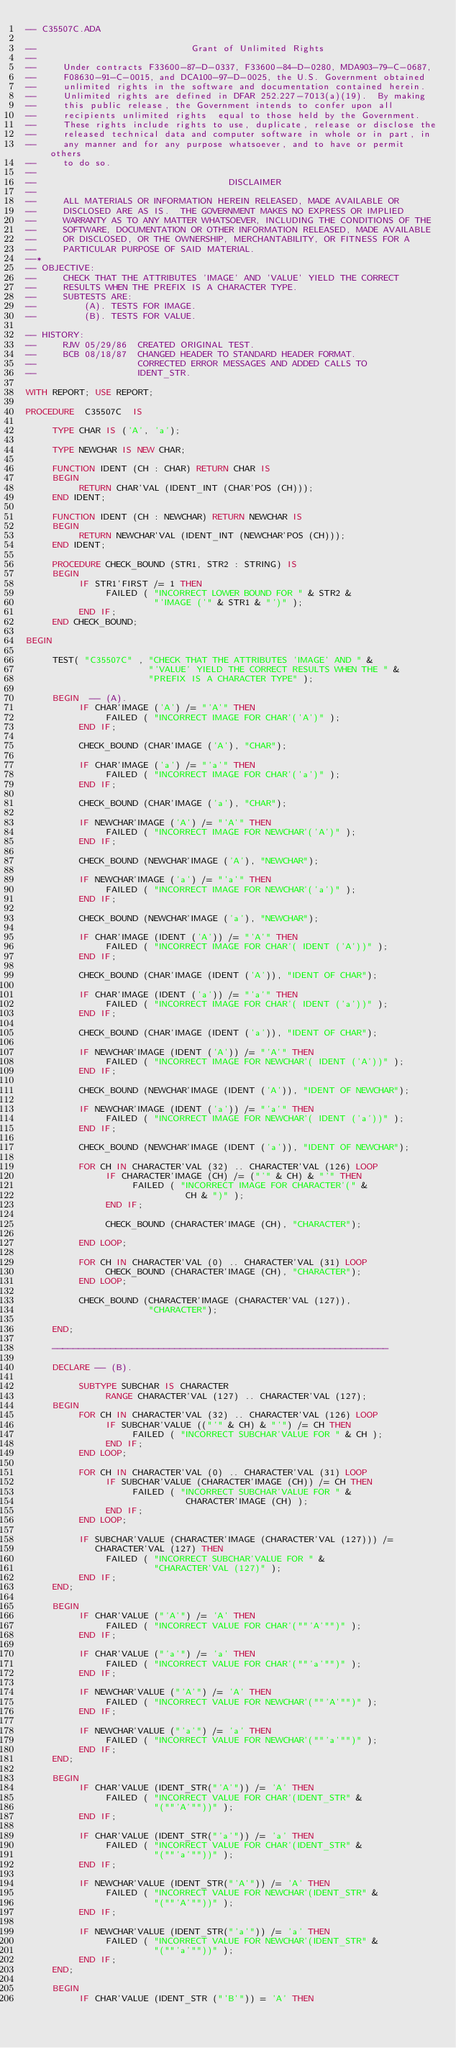Convert code to text. <code><loc_0><loc_0><loc_500><loc_500><_Ada_>-- C35507C.ADA

--                             Grant of Unlimited Rights
--
--     Under contracts F33600-87-D-0337, F33600-84-D-0280, MDA903-79-C-0687,
--     F08630-91-C-0015, and DCA100-97-D-0025, the U.S. Government obtained 
--     unlimited rights in the software and documentation contained herein.
--     Unlimited rights are defined in DFAR 252.227-7013(a)(19).  By making 
--     this public release, the Government intends to confer upon all 
--     recipients unlimited rights  equal to those held by the Government.  
--     These rights include rights to use, duplicate, release or disclose the 
--     released technical data and computer software in whole or in part, in 
--     any manner and for any purpose whatsoever, and to have or permit others 
--     to do so.
--
--                                    DISCLAIMER
--
--     ALL MATERIALS OR INFORMATION HEREIN RELEASED, MADE AVAILABLE OR
--     DISCLOSED ARE AS IS.  THE GOVERNMENT MAKES NO EXPRESS OR IMPLIED 
--     WARRANTY AS TO ANY MATTER WHATSOEVER, INCLUDING THE CONDITIONS OF THE
--     SOFTWARE, DOCUMENTATION OR OTHER INFORMATION RELEASED, MADE AVAILABLE 
--     OR DISCLOSED, OR THE OWNERSHIP, MERCHANTABILITY, OR FITNESS FOR A
--     PARTICULAR PURPOSE OF SAID MATERIAL.
--*
-- OBJECTIVE:
--     CHECK THAT THE ATTRIBUTES 'IMAGE' AND 'VALUE' YIELD THE CORRECT
--     RESULTS WHEN THE PREFIX IS A CHARACTER TYPE.
--     SUBTESTS ARE:
--         (A). TESTS FOR IMAGE.
--         (B). TESTS FOR VALUE.

-- HISTORY:
--     RJW 05/29/86  CREATED ORIGINAL TEST.
--     BCB 08/18/87  CHANGED HEADER TO STANDARD HEADER FORMAT.
--                   CORRECTED ERROR MESSAGES AND ADDED CALLS TO
--                   IDENT_STR.

WITH REPORT; USE REPORT;

PROCEDURE  C35507C  IS

     TYPE CHAR IS ('A', 'a');

     TYPE NEWCHAR IS NEW CHAR;

     FUNCTION IDENT (CH : CHAR) RETURN CHAR IS
     BEGIN
          RETURN CHAR'VAL (IDENT_INT (CHAR'POS (CH)));
     END IDENT;

     FUNCTION IDENT (CH : NEWCHAR) RETURN NEWCHAR IS
     BEGIN
          RETURN NEWCHAR'VAL (IDENT_INT (NEWCHAR'POS (CH)));
     END IDENT;

     PROCEDURE CHECK_BOUND (STR1, STR2 : STRING) IS
     BEGIN
          IF STR1'FIRST /= 1 THEN
               FAILED ( "INCORRECT LOWER BOUND FOR " & STR2 &
                        "'IMAGE ('" & STR1 & "')" );
          END IF;
     END CHECK_BOUND;

BEGIN

     TEST( "C35507C" , "CHECK THAT THE ATTRIBUTES 'IMAGE' AND " &
                       "'VALUE' YIELD THE CORRECT RESULTS WHEN THE " &
                       "PREFIX IS A CHARACTER TYPE" );

     BEGIN  -- (A).
          IF CHAR'IMAGE ('A') /= "'A'" THEN
               FAILED ( "INCORRECT IMAGE FOR CHAR'('A')" );
          END IF;

          CHECK_BOUND (CHAR'IMAGE ('A'), "CHAR");

          IF CHAR'IMAGE ('a') /= "'a'" THEN
               FAILED ( "INCORRECT IMAGE FOR CHAR'('a')" );
          END IF;

          CHECK_BOUND (CHAR'IMAGE ('a'), "CHAR");

          IF NEWCHAR'IMAGE ('A') /= "'A'" THEN
               FAILED ( "INCORRECT IMAGE FOR NEWCHAR'('A')" );
          END IF;

          CHECK_BOUND (NEWCHAR'IMAGE ('A'), "NEWCHAR");

          IF NEWCHAR'IMAGE ('a') /= "'a'" THEN
               FAILED ( "INCORRECT IMAGE FOR NEWCHAR'('a')" );
          END IF;

          CHECK_BOUND (NEWCHAR'IMAGE ('a'), "NEWCHAR");

          IF CHAR'IMAGE (IDENT ('A')) /= "'A'" THEN
               FAILED ( "INCORRECT IMAGE FOR CHAR'( IDENT ('A'))" );
          END IF;

          CHECK_BOUND (CHAR'IMAGE (IDENT ('A')), "IDENT OF CHAR");

          IF CHAR'IMAGE (IDENT ('a')) /= "'a'" THEN
               FAILED ( "INCORRECT IMAGE FOR CHAR'( IDENT ('a'))" );
          END IF;

          CHECK_BOUND (CHAR'IMAGE (IDENT ('a')), "IDENT OF CHAR");

          IF NEWCHAR'IMAGE (IDENT ('A')) /= "'A'" THEN
               FAILED ( "INCORRECT IMAGE FOR NEWCHAR'( IDENT ('A'))" );
          END IF;

          CHECK_BOUND (NEWCHAR'IMAGE (IDENT ('A')), "IDENT OF NEWCHAR");

          IF NEWCHAR'IMAGE (IDENT ('a')) /= "'a'" THEN
               FAILED ( "INCORRECT IMAGE FOR NEWCHAR'( IDENT ('a'))" );
          END IF;

          CHECK_BOUND (NEWCHAR'IMAGE (IDENT ('a')), "IDENT OF NEWCHAR");

          FOR CH IN CHARACTER'VAL (32) .. CHARACTER'VAL (126) LOOP
               IF CHARACTER'IMAGE (CH) /= ("'" & CH) & "'" THEN
                    FAILED ( "INCORRECT IMAGE FOR CHARACTER'(" &
                              CH & ")" );
               END IF;

               CHECK_BOUND (CHARACTER'IMAGE (CH), "CHARACTER");

          END LOOP;

          FOR CH IN CHARACTER'VAL (0) .. CHARACTER'VAL (31) LOOP
               CHECK_BOUND (CHARACTER'IMAGE (CH), "CHARACTER");
          END LOOP;

          CHECK_BOUND (CHARACTER'IMAGE (CHARACTER'VAL (127)),
                       "CHARACTER");

     END;

     ---------------------------------------------------------------

     DECLARE -- (B).

          SUBTYPE SUBCHAR IS CHARACTER
               RANGE CHARACTER'VAL (127) .. CHARACTER'VAL (127);
     BEGIN
          FOR CH IN CHARACTER'VAL (32) .. CHARACTER'VAL (126) LOOP
               IF SUBCHAR'VALUE (("'" & CH) & "'") /= CH THEN
                    FAILED ( "INCORRECT SUBCHAR'VALUE FOR " & CH );
               END IF;
          END LOOP;

          FOR CH IN CHARACTER'VAL (0) .. CHARACTER'VAL (31) LOOP
               IF SUBCHAR'VALUE (CHARACTER'IMAGE (CH)) /= CH THEN
                    FAILED ( "INCORRECT SUBCHAR'VALUE FOR " &
                              CHARACTER'IMAGE (CH) );
               END IF;
          END LOOP;

          IF SUBCHAR'VALUE (CHARACTER'IMAGE (CHARACTER'VAL (127))) /=
             CHARACTER'VAL (127) THEN
               FAILED ( "INCORRECT SUBCHAR'VALUE FOR " &
                        "CHARACTER'VAL (127)" );
          END IF;
     END;

     BEGIN
          IF CHAR'VALUE ("'A'") /= 'A' THEN
               FAILED ( "INCORRECT VALUE FOR CHAR'(""'A'"")" );
          END IF;

          IF CHAR'VALUE ("'a'") /= 'a' THEN
               FAILED ( "INCORRECT VALUE FOR CHAR'(""'a'"")" );
          END IF;

          IF NEWCHAR'VALUE ("'A'") /= 'A' THEN
               FAILED ( "INCORRECT VALUE FOR NEWCHAR'(""'A'"")" );
          END IF;

          IF NEWCHAR'VALUE ("'a'") /= 'a' THEN
               FAILED ( "INCORRECT VALUE FOR NEWCHAR'(""'a'"")" );
          END IF;
     END;

     BEGIN
          IF CHAR'VALUE (IDENT_STR("'A'")) /= 'A' THEN
               FAILED ( "INCORRECT VALUE FOR CHAR'(IDENT_STR" &
                        "(""'A'""))" );
          END IF;

          IF CHAR'VALUE (IDENT_STR("'a'")) /= 'a' THEN
               FAILED ( "INCORRECT VALUE FOR CHAR'(IDENT_STR" &
                        "(""'a'""))" );
          END IF;

          IF NEWCHAR'VALUE (IDENT_STR("'A'")) /= 'A' THEN
               FAILED ( "INCORRECT VALUE FOR NEWCHAR'(IDENT_STR" &
                        "(""'A'""))" );
          END IF;

          IF NEWCHAR'VALUE (IDENT_STR("'a'")) /= 'a' THEN
               FAILED ( "INCORRECT VALUE FOR NEWCHAR'(IDENT_STR" &
                        "(""'a'""))" );
          END IF;
     END;

     BEGIN
          IF CHAR'VALUE (IDENT_STR ("'B'")) = 'A' THEN</code> 